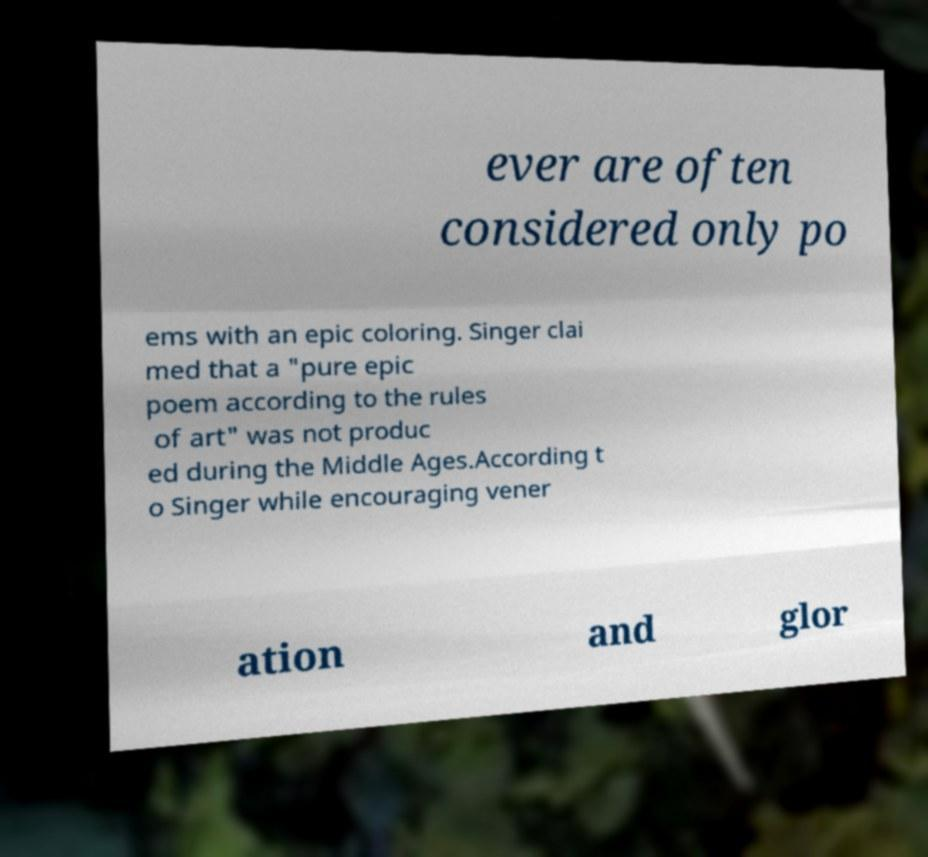There's text embedded in this image that I need extracted. Can you transcribe it verbatim? ever are often considered only po ems with an epic coloring. Singer clai med that a "pure epic poem according to the rules of art" was not produc ed during the Middle Ages.According t o Singer while encouraging vener ation and glor 